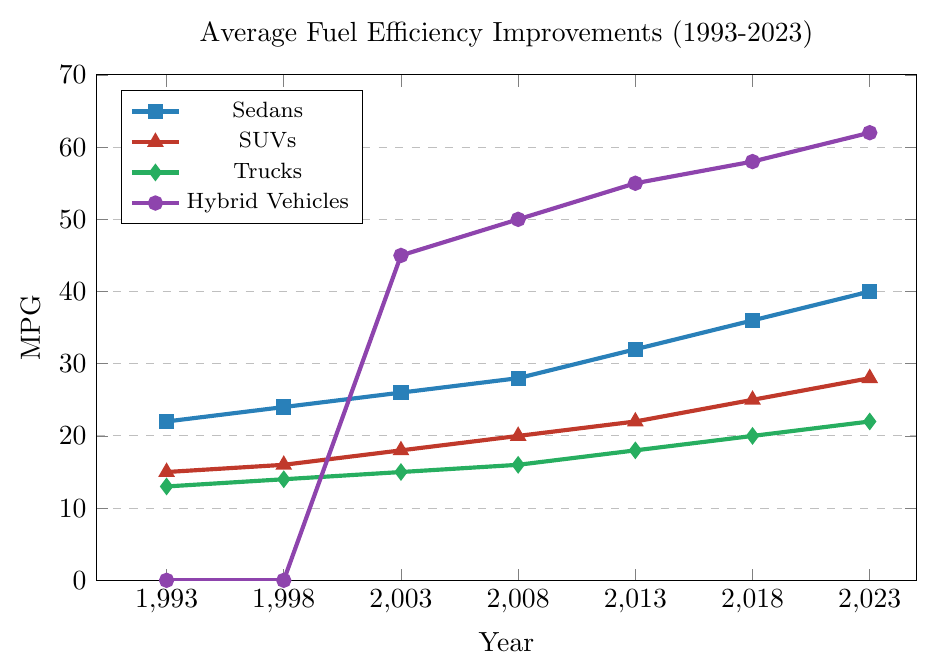What's the total increase in fuel efficiency for Sedans from 1993 to 2023? The fuel efficiency of Sedans in 1993 was 22 MPG and it increased to 40 MPG in 2023, so the total increase is 40 - 22.
Answer: 18 Which vehicle type had the largest initial increase in fuel efficiency between 1993 and 1998? Comparing the increases: Sedans increased from 22 to 24 (2 MPG), SUVs from 15 to 16 (1 MPG), Trucks from 13 to 14 (1 MPG), and Hybrid Vehicles had no increase since they were not available in 1993 and 1998.
Answer: Sedans What is the average fuel efficiency of Hybrid Vehicles from 2003 to 2023? The fuel efficiencies in years 2003, 2008, 2013, 2018, and 2023 are 45, 50, 55, 58, and 62 respectively. The average is (45 + 50 + 55 + 58 + 62) / 5.
Answer: 54 How does the fuel efficiency of SUVs in 2013 compare to that of Trucks in 2023? The fuel efficiency of SUVs in 2013 is 22 MPG and the fuel efficiency of Trucks in 2023 is 22 MPG, so they are the same.
Answer: Equal Which vehicle type experienced the greatest total improvement in fuel efficiency from 1993 to 2023? Calculating improvements: Sedans improved by 18 MPG (40-22), SUVs by 13 MPG (28-15), Trucks by 9 MPG (22-13), and Hybrid Vehicles improved by 62 MPG (62-0).
Answer: Hybrid Vehicles What is the sum of fuel efficiencies for all vehicle types in the year 2008? Adding fuel efficiencies in 2008: Sedans 28 MPG, SUVs 20 MPG, Trucks 16 MPG, Hybrid Vehicles 50 MPG. The sum is 28 + 20 + 16 + 50.
Answer: 114 Which color represents the trend line for Hybrid Vehicles? By observing the colors used in the plot, the line representing Hybrid Vehicles is marked with purple.
Answer: Purple Between which two consecutive years did SUVs see the largest increase in fuel efficiency? Examining the fuel efficiency increases: 1993-1998 (1 MPG), 1998-2003 (2 MPG), 2003-2008 (2 MPG), 2008-2013 (2 MPG), 2013-2018 (3 MPG), 2018-2023 (3 MPG). The largest increase is between 2013-2018 and 2018-2023.
Answer: 2013 and 2018 By how much did Truck fuel efficiency increase from 2003 to 2013? The fuel efficiency in 2003 was 15 MPG and in 2013 it was 18 MPG, so the increase is 18 - 15.
Answer: 3 What is the difference in fuel efficiency between Sedans and SUVs in the year 2023? The fuel efficiency of Sedans in 2023 is 40 MPG and for SUVs it is 28 MPG, so the difference is 40 - 28.
Answer: 12 